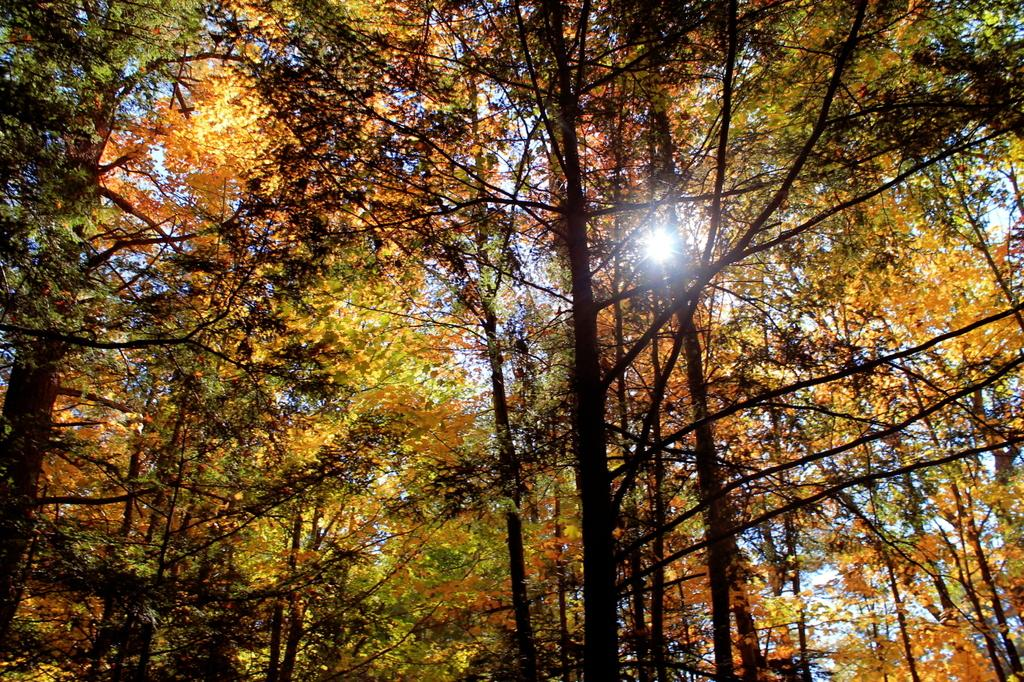Where was the image taken? The image was taken outdoors. What can be seen in the image besides the sky? There are many trees in the image. What is visible in the background of the image? The sky is visible in the background of the image. Can the sun be seen in the image? Yes, the sun is observable in the sky. What type of cake is being served at the picnic in the image? There is no picnic or cake present in the image; it features trees and a sky with the sun. What color is the skirt of the woman walking in the image? There is no woman or skirt present in the image. 